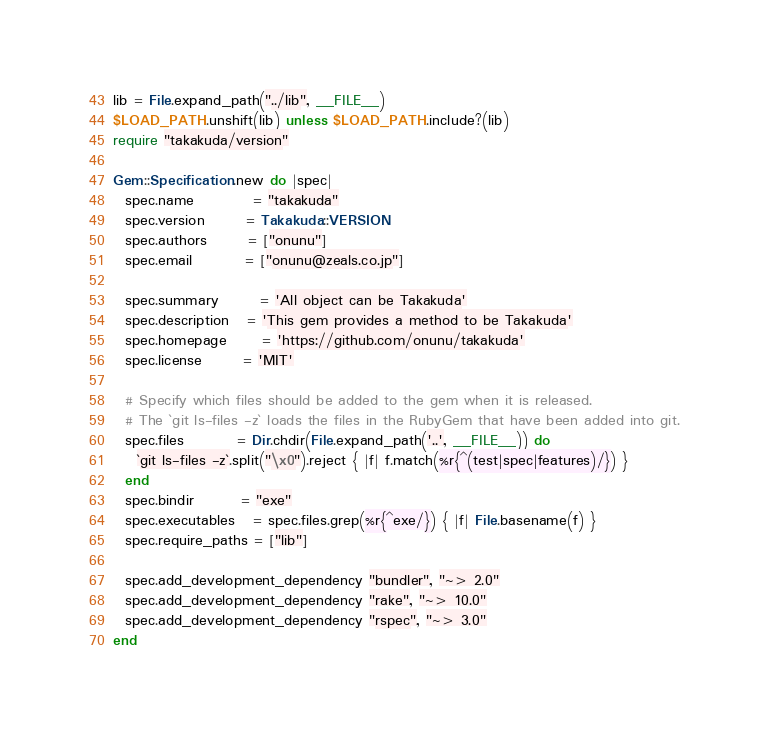Convert code to text. <code><loc_0><loc_0><loc_500><loc_500><_Ruby_>lib = File.expand_path("../lib", __FILE__)
$LOAD_PATH.unshift(lib) unless $LOAD_PATH.include?(lib)
require "takakuda/version"

Gem::Specification.new do |spec|
  spec.name          = "takakuda"
  spec.version       = Takakuda::VERSION
  spec.authors       = ["onunu"]
  spec.email         = ["onunu@zeals.co.jp"]

  spec.summary       = 'All object can be Takakuda'
  spec.description   = 'This gem provides a method to be Takakuda'
  spec.homepage      = 'https://github.com/onunu/takakuda'
  spec.license       = 'MIT'

  # Specify which files should be added to the gem when it is released.
  # The `git ls-files -z` loads the files in the RubyGem that have been added into git.
  spec.files         = Dir.chdir(File.expand_path('..', __FILE__)) do
    `git ls-files -z`.split("\x0").reject { |f| f.match(%r{^(test|spec|features)/}) }
  end
  spec.bindir        = "exe"
  spec.executables   = spec.files.grep(%r{^exe/}) { |f| File.basename(f) }
  spec.require_paths = ["lib"]

  spec.add_development_dependency "bundler", "~> 2.0"
  spec.add_development_dependency "rake", "~> 10.0"
  spec.add_development_dependency "rspec", "~> 3.0"
end
</code> 